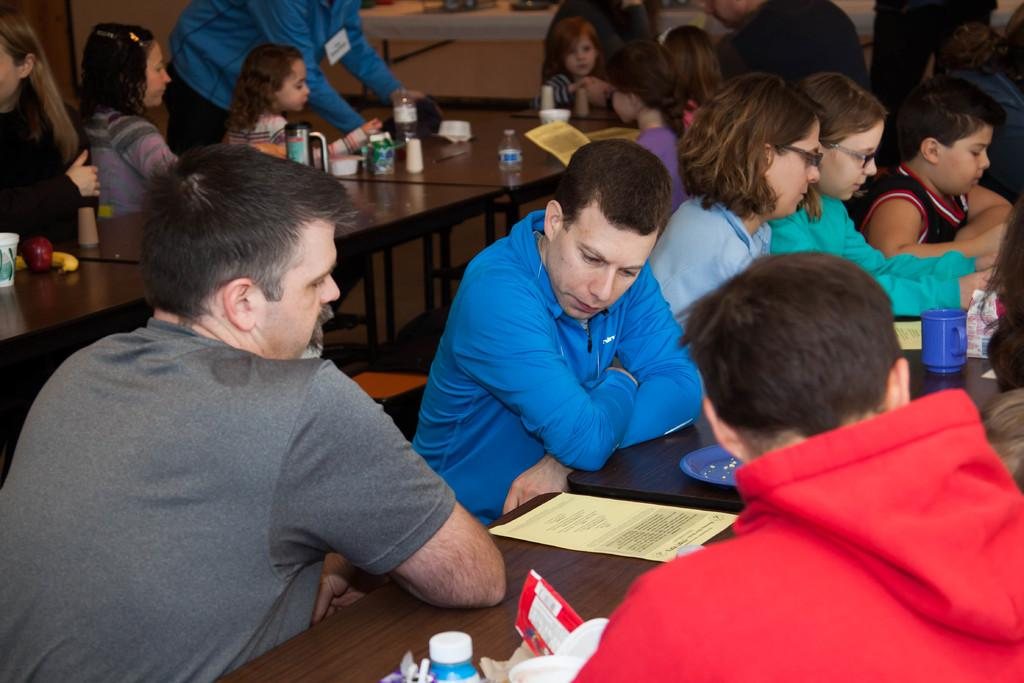How many people are in the image? There is a group of persons in the image, but the exact number cannot be determined from the provided facts. What are the persons in the image doing? The persons are sitting at tables in the image. What items can be seen on the tables? There is a cup, a paper, a plate, bottles, glasses, an apple, and a banana on the tables in the image. What is visible in the background of the image? There is a wall in the background of the image. What type of honey is being served in the glasses on the table? There is no honey present in the image; only a cup, a paper, a plate, bottles, glasses, an apple, and a banana are visible on the tables. What time of day is it in the image, based on the hour? The provided facts do not mention any specific time or hour, so it is not possible to determine the time of day in the image. 